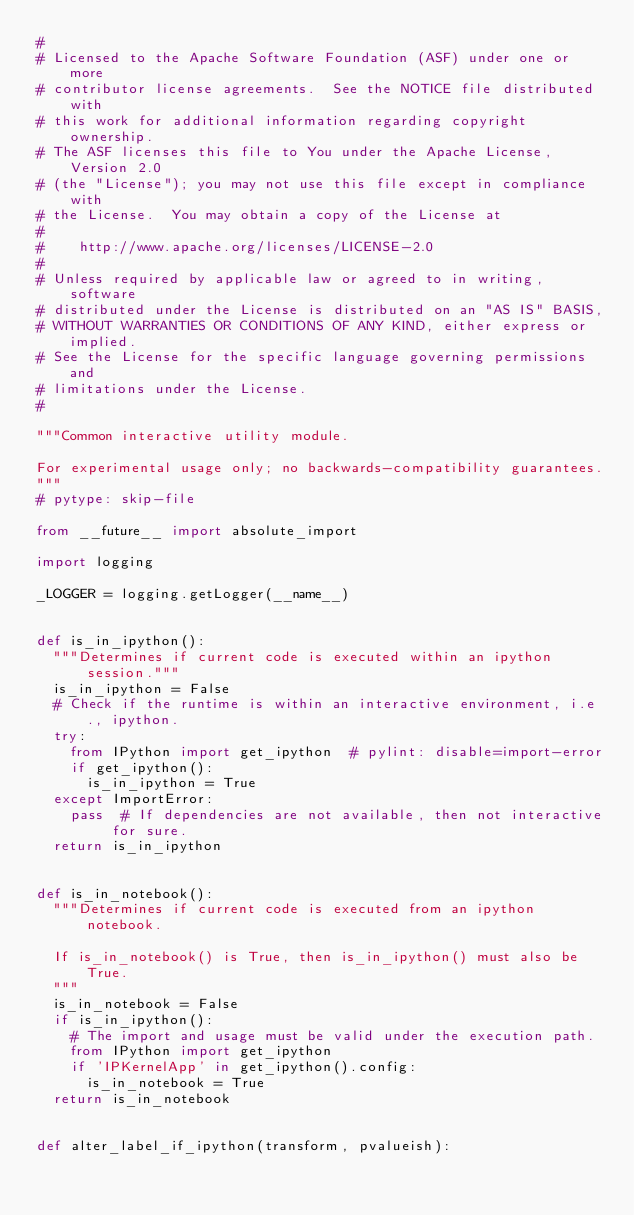Convert code to text. <code><loc_0><loc_0><loc_500><loc_500><_Python_>#
# Licensed to the Apache Software Foundation (ASF) under one or more
# contributor license agreements.  See the NOTICE file distributed with
# this work for additional information regarding copyright ownership.
# The ASF licenses this file to You under the Apache License, Version 2.0
# (the "License"); you may not use this file except in compliance with
# the License.  You may obtain a copy of the License at
#
#    http://www.apache.org/licenses/LICENSE-2.0
#
# Unless required by applicable law or agreed to in writing, software
# distributed under the License is distributed on an "AS IS" BASIS,
# WITHOUT WARRANTIES OR CONDITIONS OF ANY KIND, either express or implied.
# See the License for the specific language governing permissions and
# limitations under the License.
#

"""Common interactive utility module.

For experimental usage only; no backwards-compatibility guarantees.
"""
# pytype: skip-file

from __future__ import absolute_import

import logging

_LOGGER = logging.getLogger(__name__)


def is_in_ipython():
  """Determines if current code is executed within an ipython session."""
  is_in_ipython = False
  # Check if the runtime is within an interactive environment, i.e., ipython.
  try:
    from IPython import get_ipython  # pylint: disable=import-error
    if get_ipython():
      is_in_ipython = True
  except ImportError:
    pass  # If dependencies are not available, then not interactive for sure.
  return is_in_ipython


def is_in_notebook():
  """Determines if current code is executed from an ipython notebook.

  If is_in_notebook() is True, then is_in_ipython() must also be True.
  """
  is_in_notebook = False
  if is_in_ipython():
    # The import and usage must be valid under the execution path.
    from IPython import get_ipython
    if 'IPKernelApp' in get_ipython().config:
      is_in_notebook = True
  return is_in_notebook


def alter_label_if_ipython(transform, pvalueish):</code> 